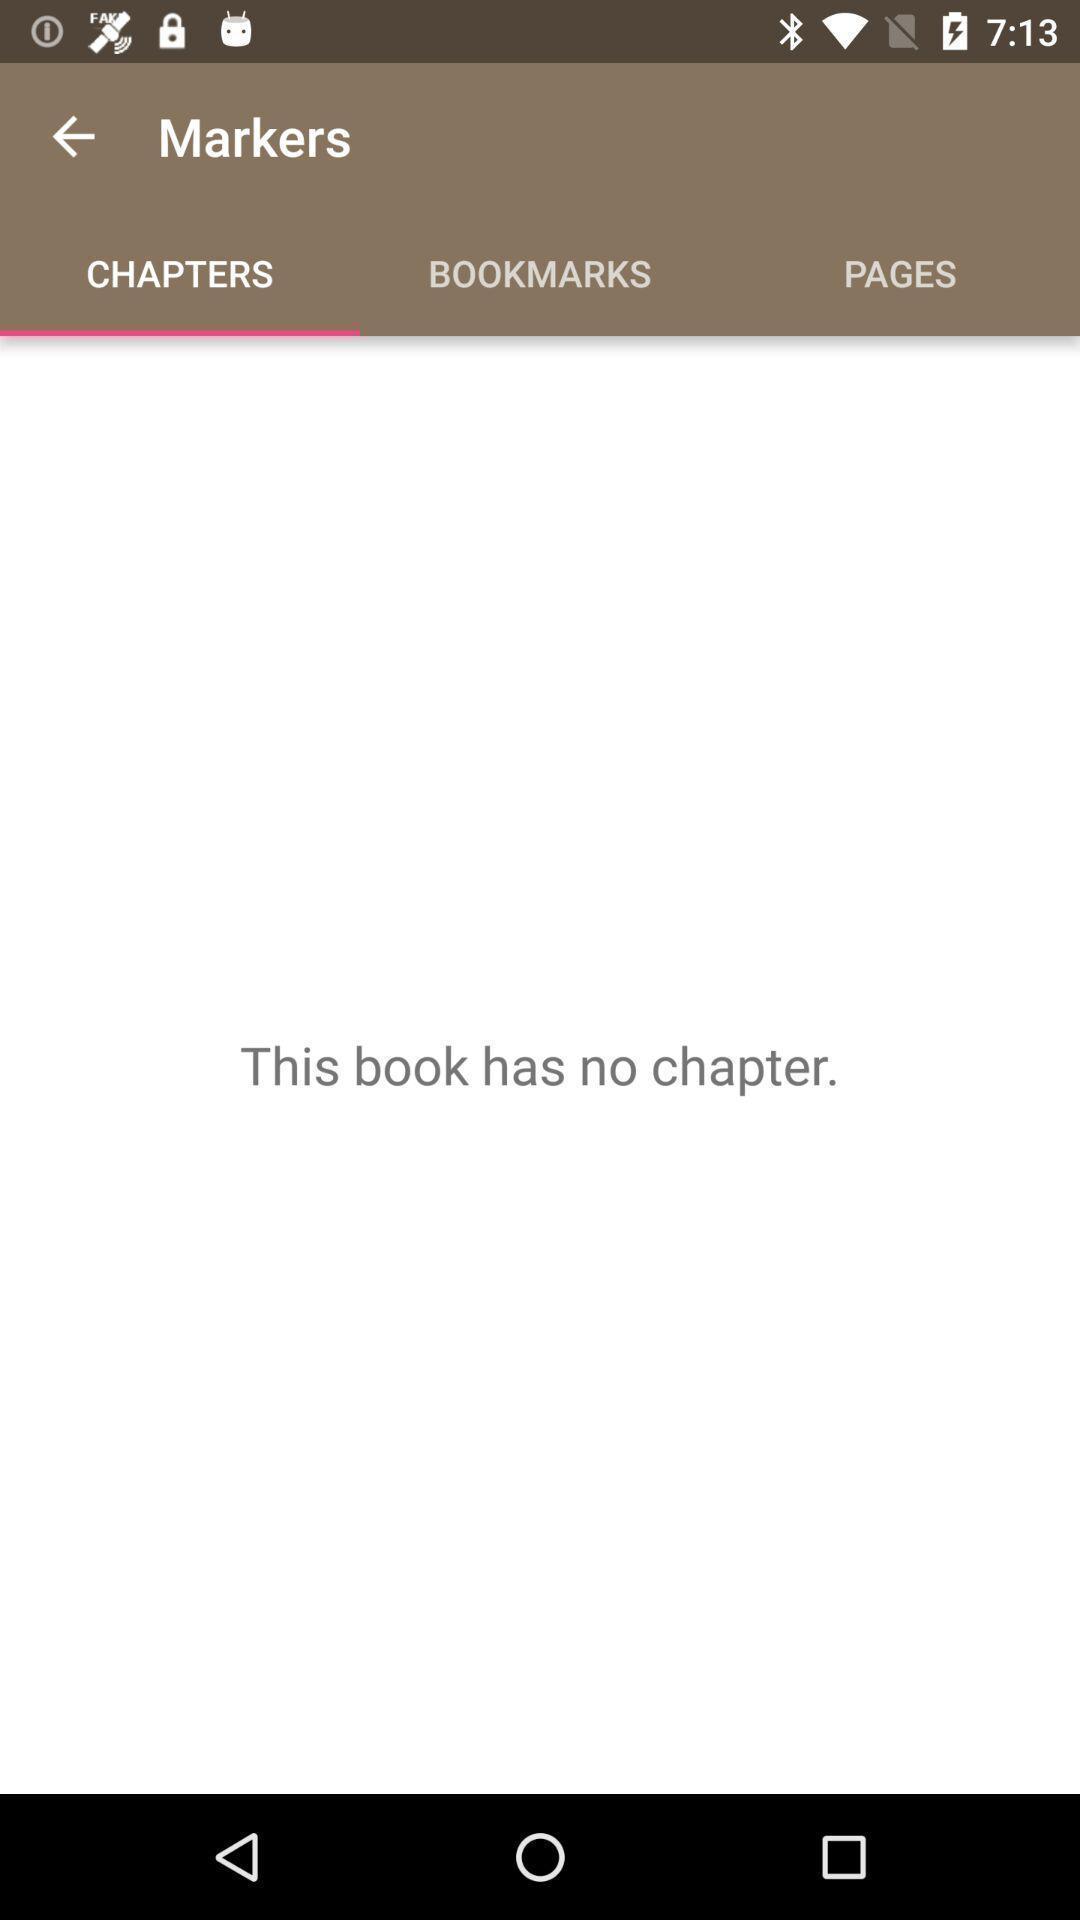Summarize the main components in this picture. Screen displaying about no chapters found. 